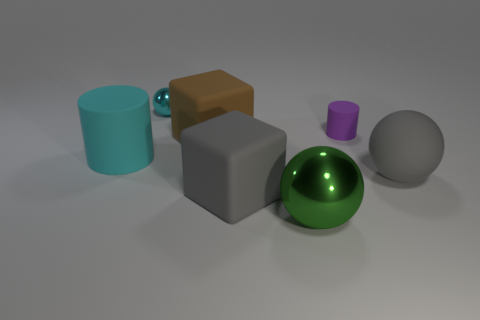Add 2 big green objects. How many objects exist? 9 Subtract all cubes. How many objects are left? 5 Subtract all tiny rubber objects. Subtract all cyan rubber objects. How many objects are left? 5 Add 2 gray matte spheres. How many gray matte spheres are left? 3 Add 3 large red rubber spheres. How many large red rubber spheres exist? 3 Subtract 1 gray balls. How many objects are left? 6 